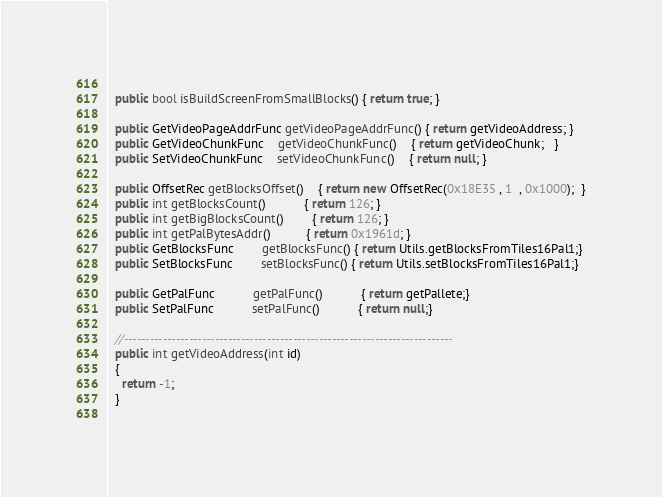<code> <loc_0><loc_0><loc_500><loc_500><_C#_>  
  public bool isBuildScreenFromSmallBlocks() { return true; }
  
  public GetVideoPageAddrFunc getVideoPageAddrFunc() { return getVideoAddress; }
  public GetVideoChunkFunc    getVideoChunkFunc()    { return getVideoChunk;   }
  public SetVideoChunkFunc    setVideoChunkFunc()    { return null; }
  
  public OffsetRec getBlocksOffset()    { return new OffsetRec(0x18E35 , 1  , 0x1000);  }
  public int getBlocksCount()           { return 126; }
  public int getBigBlocksCount()        { return 126; }
  public int getPalBytesAddr()          { return 0x1961d; }
  public GetBlocksFunc        getBlocksFunc() { return Utils.getBlocksFromTiles16Pal1;}
  public SetBlocksFunc        setBlocksFunc() { return Utils.setBlocksFromTiles16Pal1;}
  
  public GetPalFunc           getPalFunc()           { return getPallete;}
  public SetPalFunc           setPalFunc()           { return null;}
  
  //----------------------------------------------------------------------------
  public int getVideoAddress(int id)
  {
    return -1;
  }
  </code> 